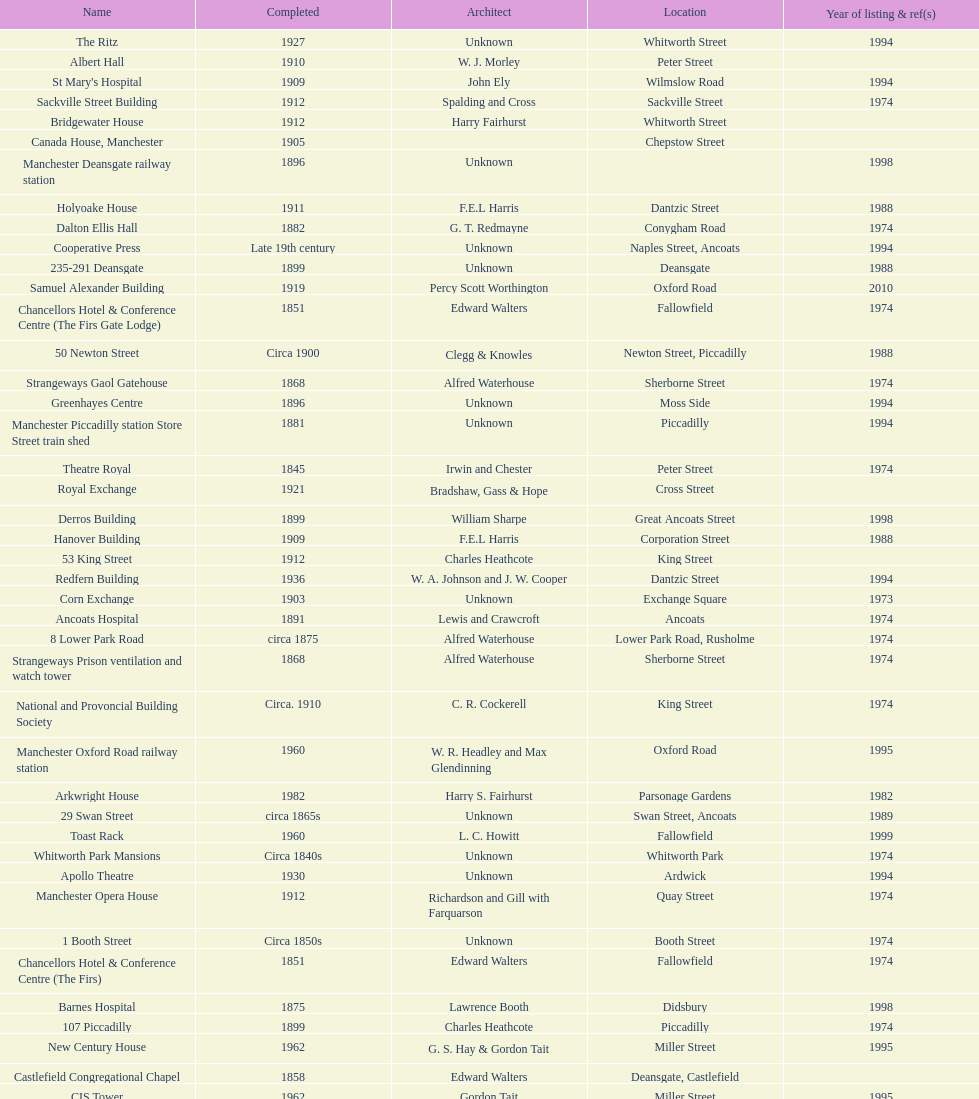How many buildings has the same year of listing as 1974? 15. 